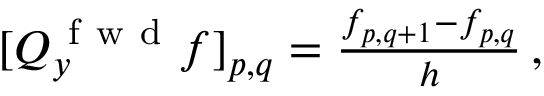Convert formula to latex. <formula><loc_0><loc_0><loc_500><loc_500>\begin{array} { r } { [ Q _ { y } ^ { f w d } f ] _ { p , q } = \frac { f _ { p , q + 1 } - f _ { p , q } } { h } \, , } \end{array}</formula> 